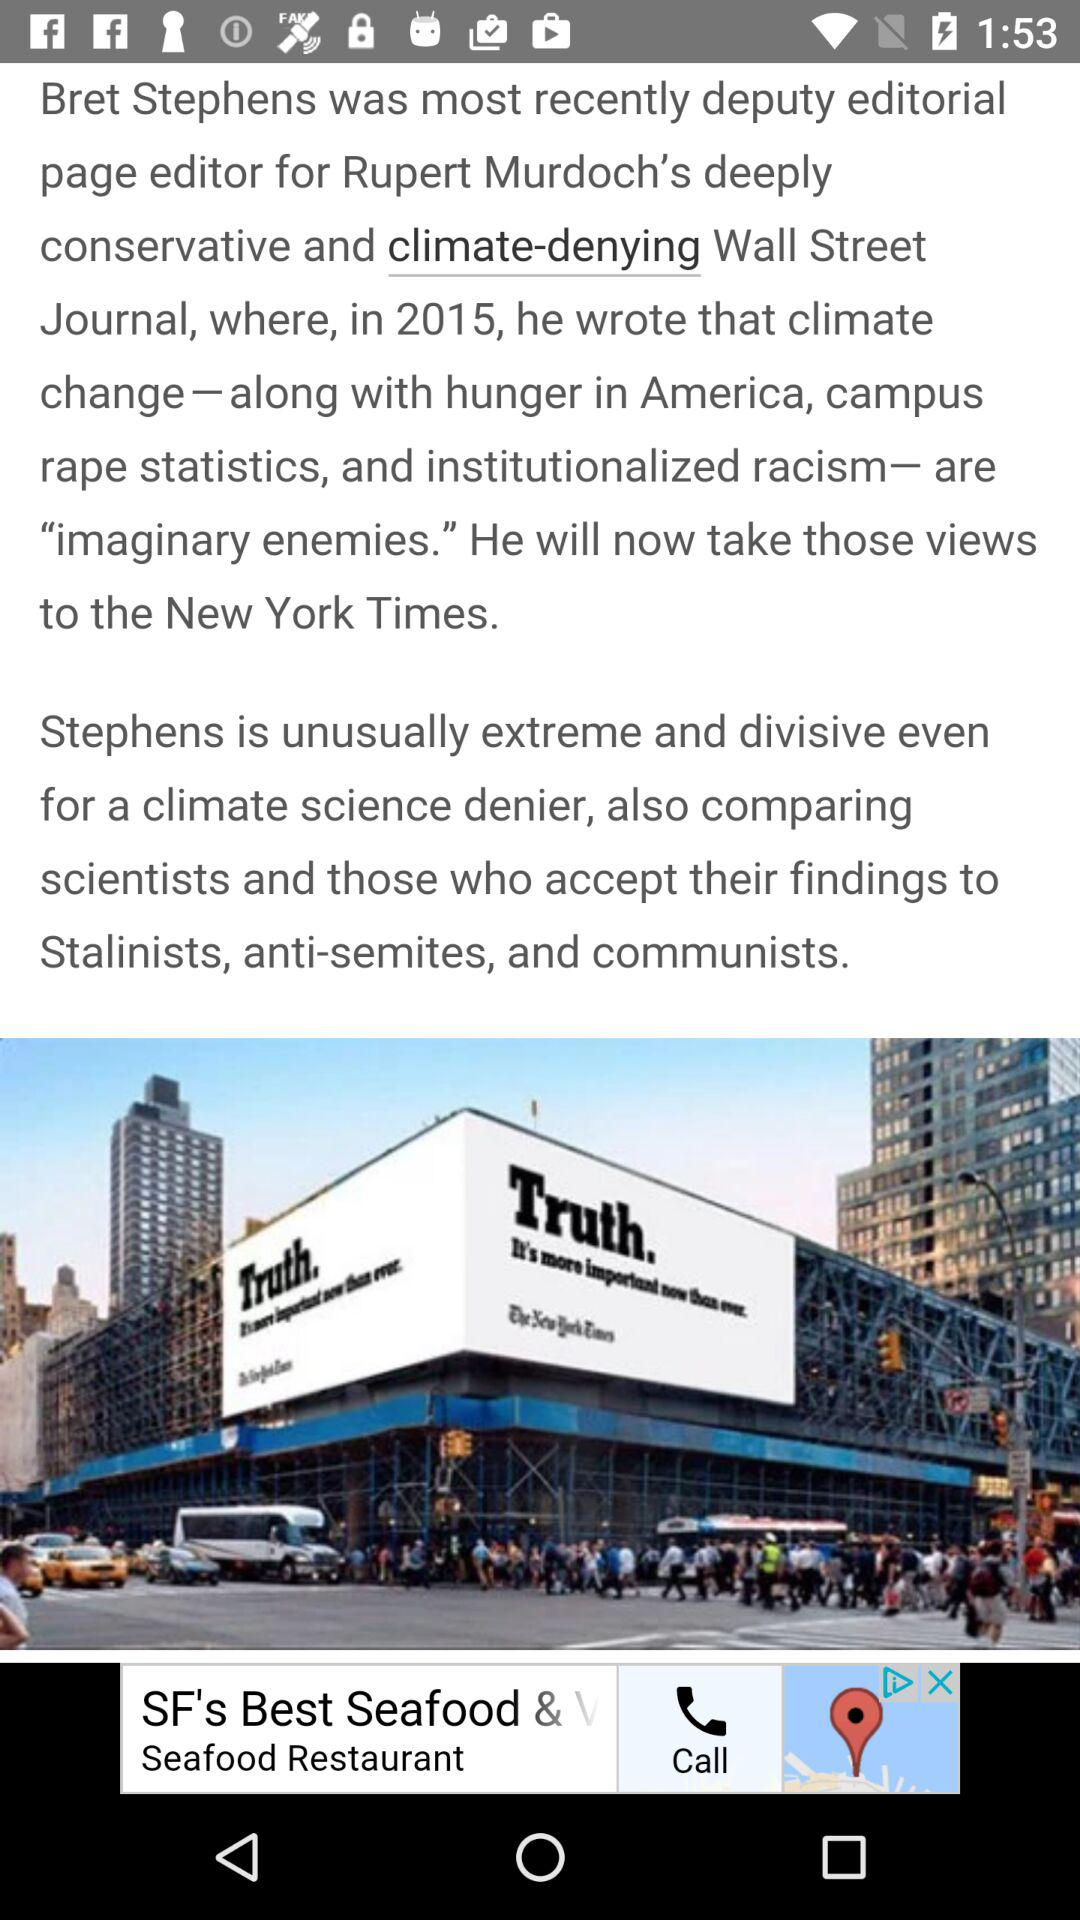Who is Bret Stephens? Bret Stephens is deputy editorial page editor for Rupert Murdoch's deeply conservative and climate-denying Wall Street Journal. 